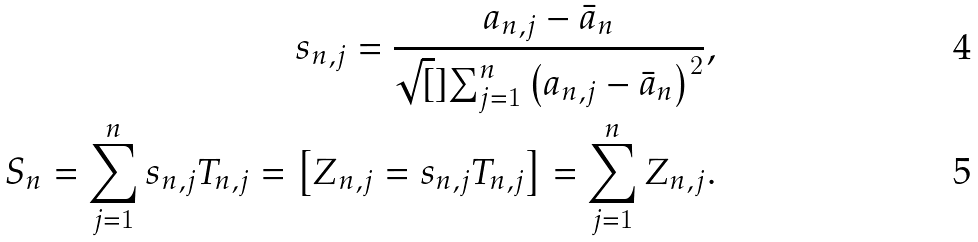<formula> <loc_0><loc_0><loc_500><loc_500>s _ { n , j } = \frac { a _ { n , j } - \bar { a } _ { n } } { \sqrt { [ } ] { \sum _ { j = 1 } ^ { n } \left ( a _ { n , j } - \bar { a } _ { n } \right ) ^ { 2 } } } , \\ S _ { n } = \sum _ { j = 1 } ^ { n } s _ { n , j } T _ { n , j } = \left [ Z _ { n , j } = s _ { n , j } T _ { n , j } \right ] = \sum _ { j = 1 } ^ { n } Z _ { n , j } .</formula> 